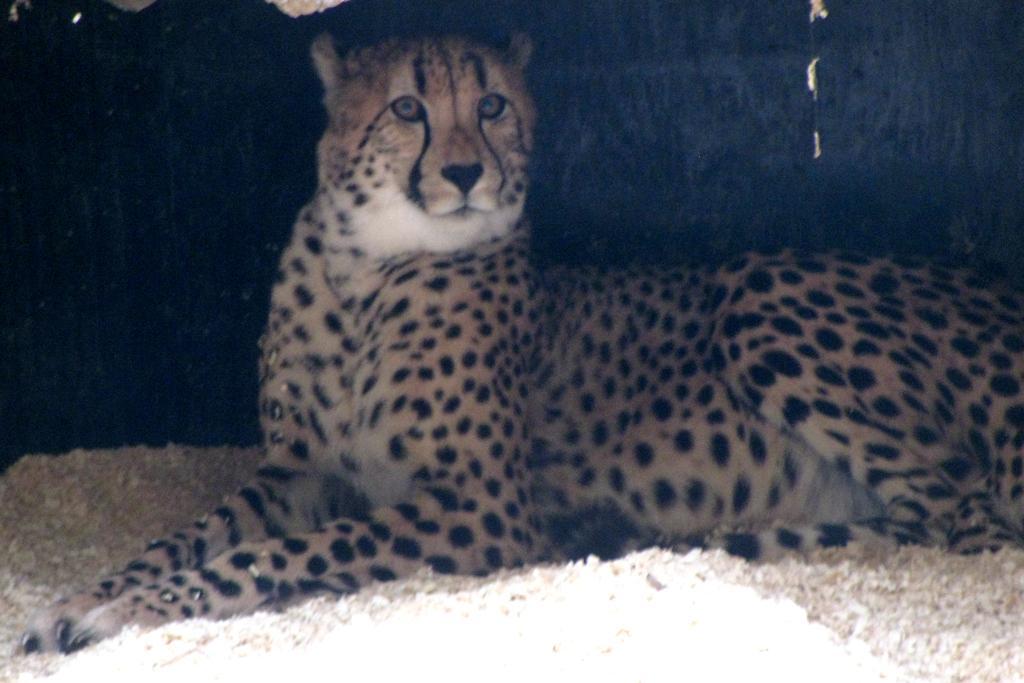Please provide a concise description of this image. In this image I can see an animal in brown,white and black color. Background is in black color. 